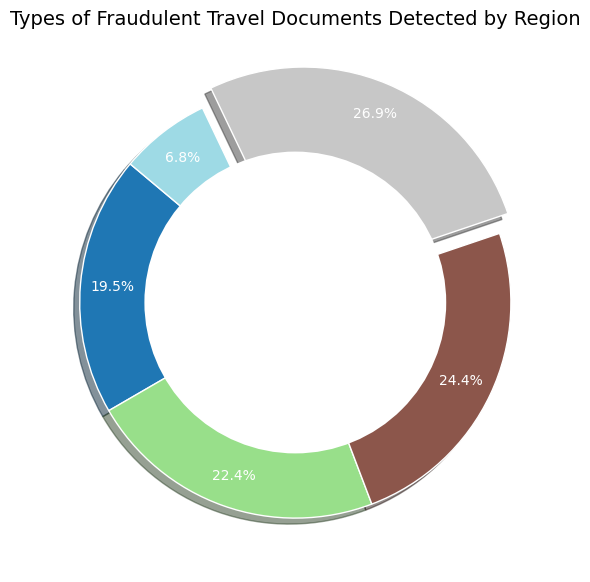What region has the highest percentage of detected fraudulent travel documents? The region with the largest wedge in the pie chart is highlighted with an explode effect, making it stand out. From visual analysis, Europe has the biggest section in the pie chart.
Answer: Europe Which region detected the least amount of fraudulent travel documents? By examining the smallest wedge in the pie chart, Oceania has the smallest section, indicating that it detected the least amount of fraudulent documents.
Answer: Oceania Is the total count of detected fraudulent documents in the Americas greater than in Africa? By comparing the sizes of the wedges, it appears that the Americas has a larger section than Africa. Adding up the counts: Americas (250 + 100 + 150 + 175 + 50 = 725) and Africa (200 + 90 + 140 + 160 + 40 = 630). Thus, the Americas has more detected documents.
Answer: Yes What is the combined percentage of detected fraudulent documents from Europe and Asia? Checking the pie chart percentages for Europe (34.7%) and Asia (30.4%) and adding them together gives (34.7% + 30.4% = 65.1%).
Answer: 65.1% How does the detection rate of forged passports in Europe compare to Asia? From the data, Europe detected 300 forged passports while Asia detected 270 forged passports. Europe’s wedge is slightly larger compared to Asia's. Thus, Europe detected more forged passports than Asia.
Answer: Europe detected more Which region has the largest wedge in the pie chart, and by what percentage does it surpass the second-largest region? The largest wedge is Europe. The second-largest is Asia. Europe's percentage is 34.7% and Asia's is 30.4%. The difference is (34.7% - 30.4% = 4.3%).
Answer: Europe; 4.3% Does Africa or Oceania have a larger detection count for altered visas? Observing the sizes of the wedges corresponding to Africa and Oceania, Africa's wedge is noticeably larger than Oceania’s. Reviewing the data confirms: Africa detected 140 altered visas, while Oceania detected 50.
Answer: Africa What is the ratio of total detected documents between the Americas and Oceania? The total count for the Americas is 725, and for Oceania, it is 220. The ratio is calculated by (725 / 220 = 3.3).
Answer: 3.3 Which region's detection count is closest to the sum of Africa's and Oceania's detection counts? Summing Africa’s and Oceania's counts: Africa (630) + Oceania (220) = 850. Comparing other regions' totals: Americas (725), Europe (870), and Asia (790). Europe’s total of 870 is the closest to 850.
Answer: Europe 